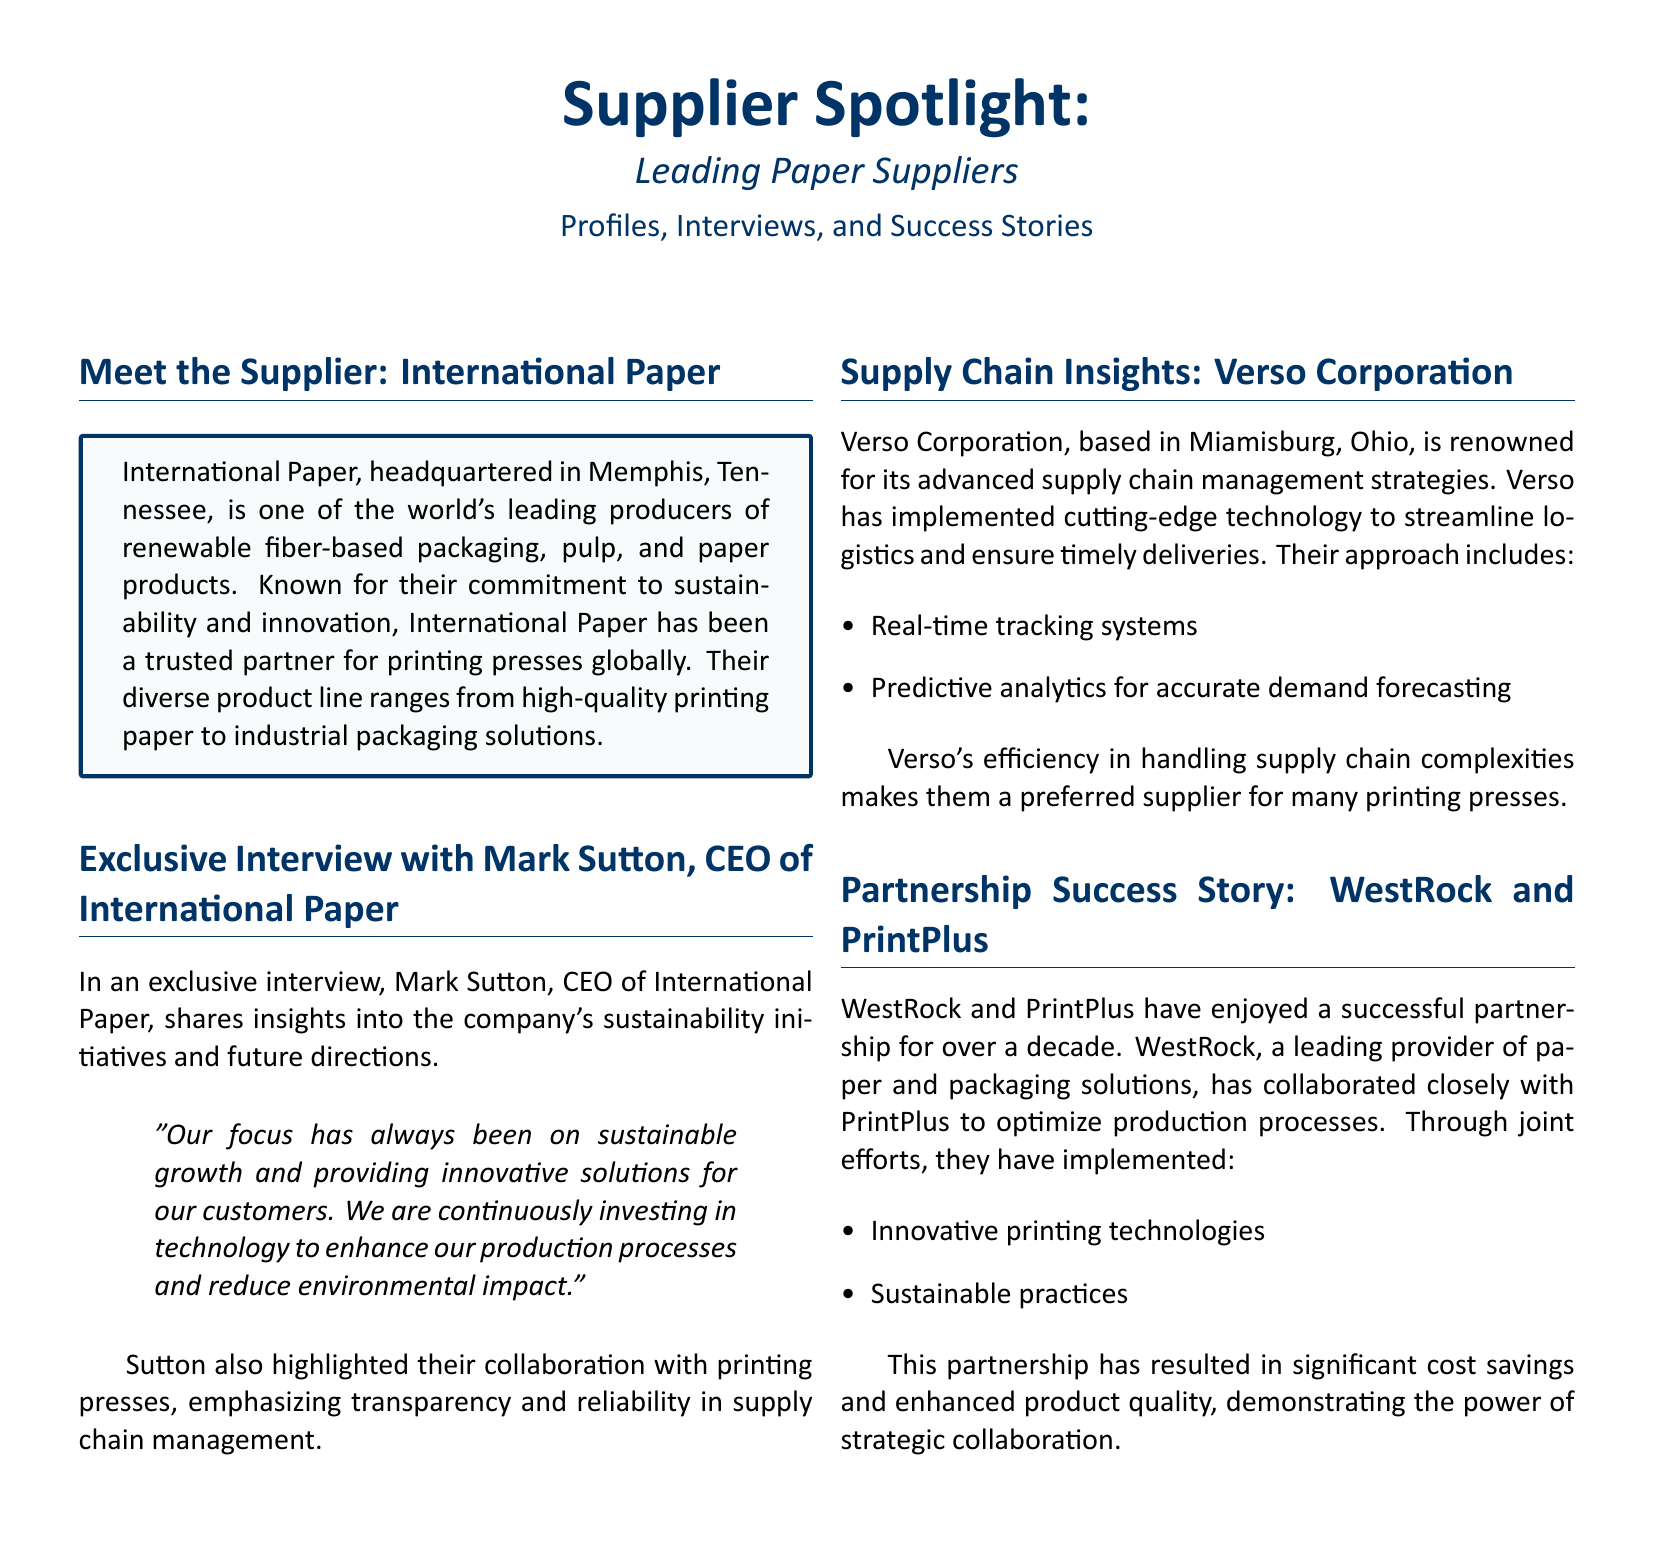What is the headquarters location of International Paper? The document specifies that International Paper is headquartered in Memphis, Tennessee.
Answer: Memphis, Tennessee Who is the CEO of International Paper? The document mentions that Mark Sutton is the CEO of International Paper.
Answer: Mark Sutton What is a notable feature of Verso Corporation's supply chain management? The document highlights that Verso Corporation uses real-time tracking systems in their supply chain management.
Answer: Real-time tracking systems How long has WestRock and PrintPlus been partners? The document states that WestRock and PrintPlus have enjoyed a partnership for over a decade.
Answer: Over a decade What type of products does International Paper produce? The document indicates that International Paper produces renewable fiber-based packaging, pulp, and paper products.
Answer: Renewable fiber-based packaging, pulp, and paper products What is a key aspect of WestRock and PrintPlus's collaboration? The document describes that they have implemented innovative printing technologies as part of their collaboration.
Answer: Innovative printing technologies What is a primary goal mentioned by Mark Sutton for International Paper? Mark Sutton mentioned in the interview that the focus is on sustainable growth for International Paper.
Answer: Sustainable growth What advanced technology does Verso Corporation use for demand forecasting? The document notes that Verso Corporation employs predictive analytics for accurate demand forecasting.
Answer: Predictive analytics 